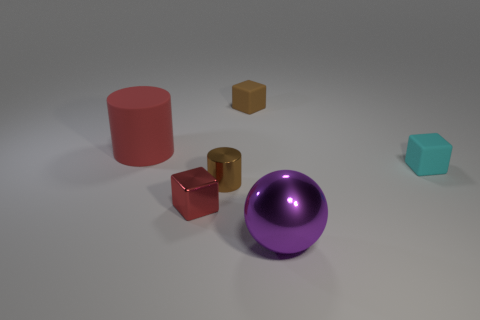Subtract all matte blocks. How many blocks are left? 1 Subtract all brown blocks. How many blocks are left? 2 Add 4 big matte cylinders. How many objects exist? 10 Subtract all balls. How many objects are left? 5 Add 4 purple shiny cylinders. How many purple shiny cylinders exist? 4 Subtract 0 yellow cubes. How many objects are left? 6 Subtract 1 cylinders. How many cylinders are left? 1 Subtract all yellow balls. Subtract all gray cubes. How many balls are left? 1 Subtract all blue blocks. How many red cylinders are left? 1 Subtract all big cyan matte spheres. Subtract all small cyan cubes. How many objects are left? 5 